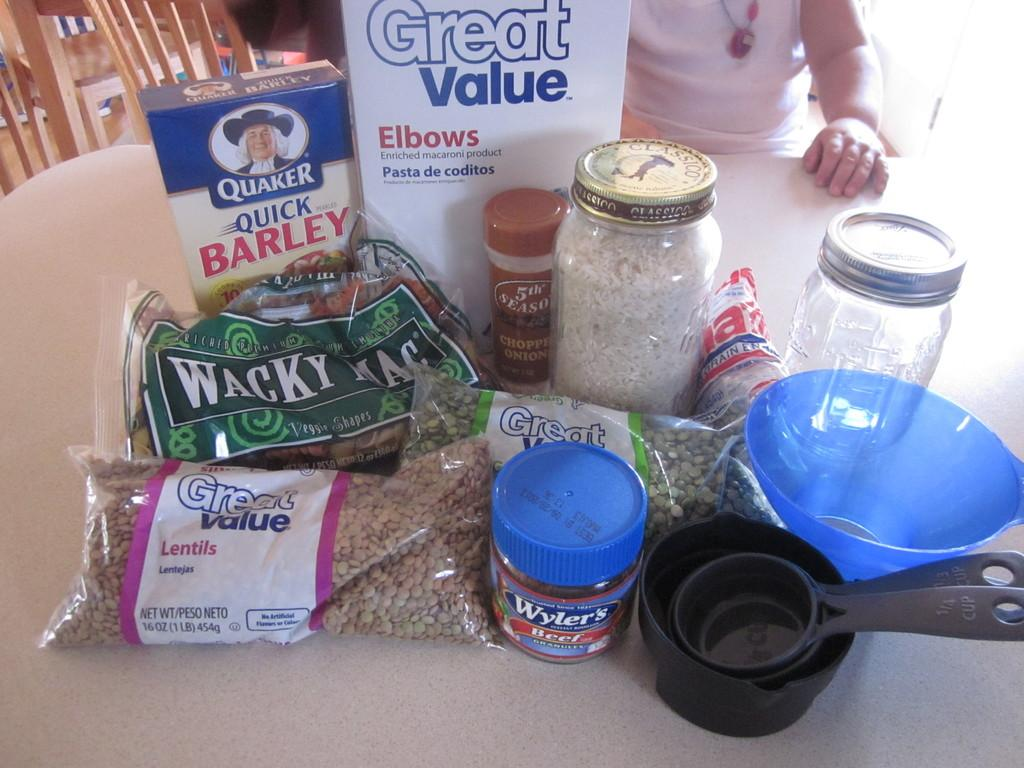<image>
Relay a brief, clear account of the picture shown. A collection of dry goods, a few of them by Great Value, sit on a table. 